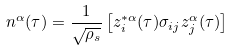<formula> <loc_0><loc_0><loc_500><loc_500>n ^ { \alpha } ( \tau ) = \frac { 1 } { \sqrt { \rho _ { s } } } \left [ z _ { i } ^ { * \alpha } ( \tau ) \sigma _ { i j } z _ { j } ^ { \alpha } ( \tau ) \right ]</formula> 